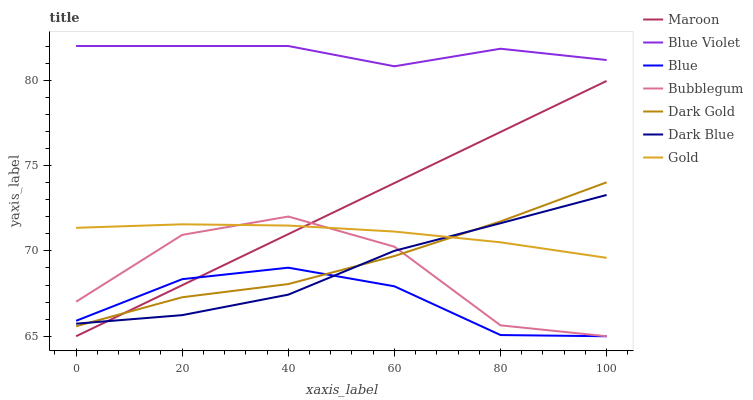Does Blue have the minimum area under the curve?
Answer yes or no. Yes. Does Blue Violet have the maximum area under the curve?
Answer yes or no. Yes. Does Gold have the minimum area under the curve?
Answer yes or no. No. Does Gold have the maximum area under the curve?
Answer yes or no. No. Is Maroon the smoothest?
Answer yes or no. Yes. Is Bubblegum the roughest?
Answer yes or no. Yes. Is Gold the smoothest?
Answer yes or no. No. Is Gold the roughest?
Answer yes or no. No. Does Blue have the lowest value?
Answer yes or no. Yes. Does Gold have the lowest value?
Answer yes or no. No. Does Blue Violet have the highest value?
Answer yes or no. Yes. Does Gold have the highest value?
Answer yes or no. No. Is Dark Blue less than Blue Violet?
Answer yes or no. Yes. Is Blue Violet greater than Dark Gold?
Answer yes or no. Yes. Does Blue intersect Bubblegum?
Answer yes or no. Yes. Is Blue less than Bubblegum?
Answer yes or no. No. Is Blue greater than Bubblegum?
Answer yes or no. No. Does Dark Blue intersect Blue Violet?
Answer yes or no. No. 